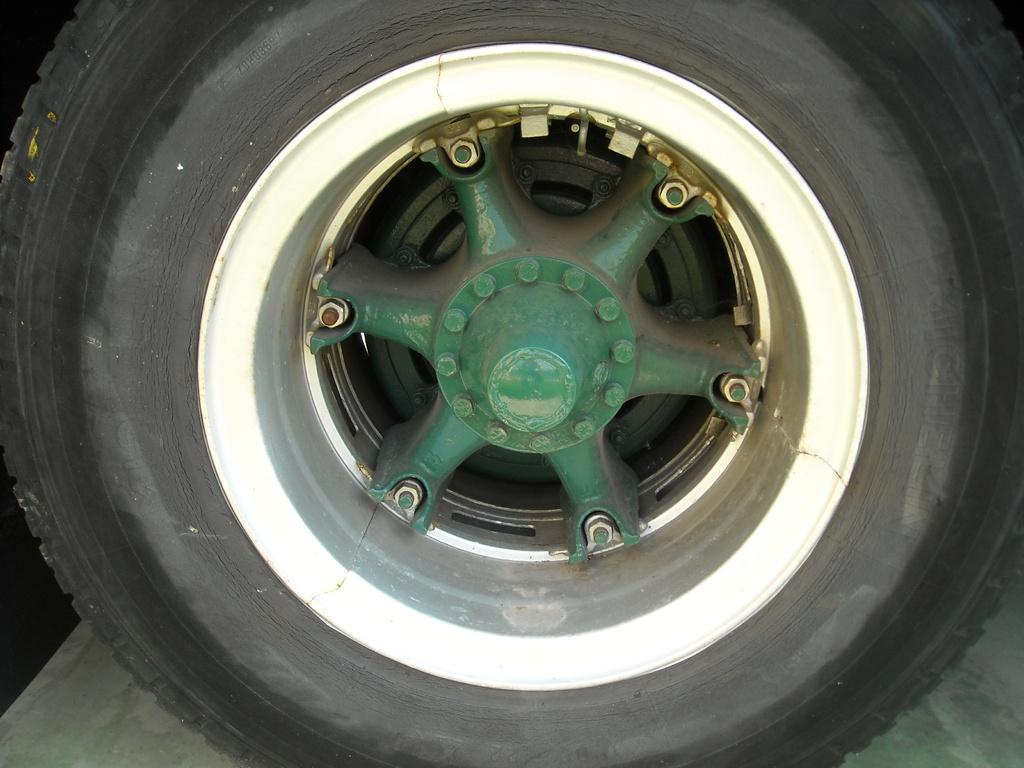What object is the main focus of the image? There is a tire in the image. Can you describe the tire's position or location in the image? The tire is on a surface. What color is the ink on the hydrant in the image? There is no hydrant or ink present in the image; it only features a tire on a surface. 